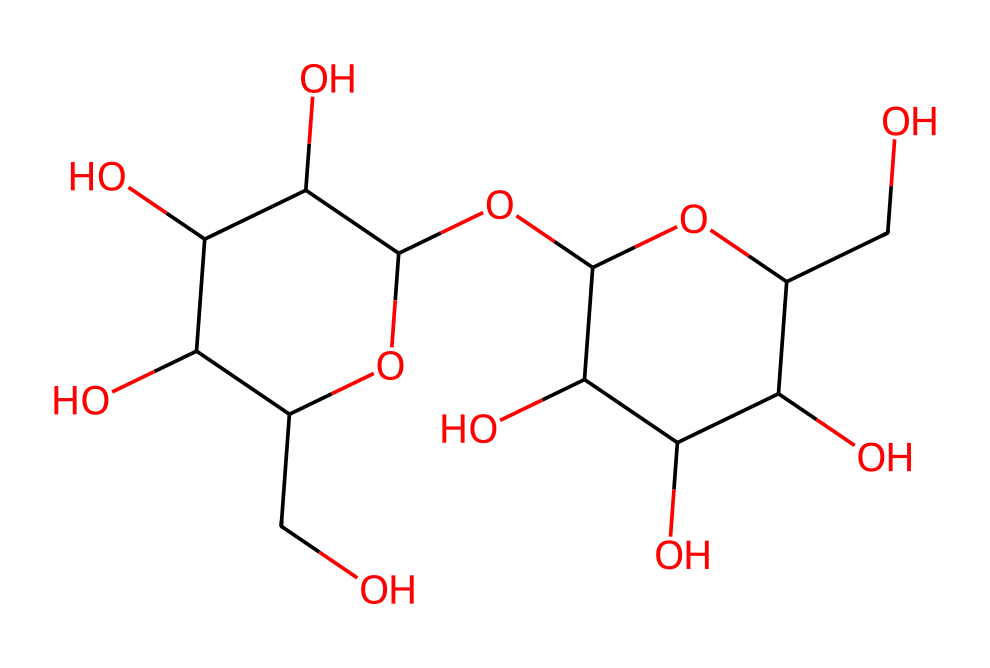What type of carbohydrate is lactose? Lactose is classified as a disaccharide, which means it is made up of two monosaccharides (glucose and galactose) linked together.
Answer: disaccharide How many carbon atoms are in lactose? By analyzing the SMILES structure, we can count the number of carbon atoms present, which is 12.
Answer: 12 What functional groups are present in lactose? Lactose contains multiple hydroxyl (-OH) groups, which are characteristic of alcohols, and an ether group due to its glycosidic bond.
Answer: hydroxyl and ether What are the two monosaccharides that make up lactose? The two monosaccharides present in lactose are glucose and galactose, which are bonded together in its structure.
Answer: glucose and galactose What is the total number of oxygen atoms in lactose? By looking at the chemical structure, we can identify the number of oxygen atoms, which is 6 in total.
Answer: 6 How many hydroxyl groups does lactose have? Upon examining the structure of lactose, we can count the number of hydroxyl groups (–OH), which is 5.
Answer: 5 What type of bond links the two monosaccharides in lactose? The two monosaccharides in lactose are linked by a glycosidic bond, which is a type of covalent bond formed between them.
Answer: glycosidic bond 